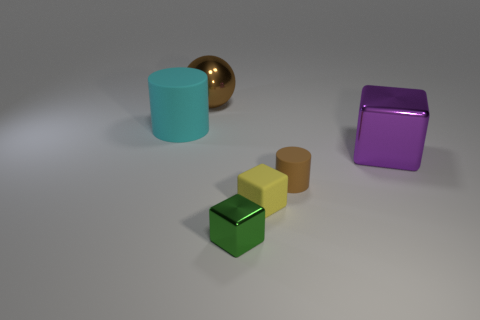How many other big cyan rubber objects have the same shape as the large rubber object?
Ensure brevity in your answer.  0. There is a block that is the same size as the yellow thing; what is its color?
Your answer should be very brief. Green. Are there the same number of big cyan objects right of the large matte cylinder and cylinders in front of the big purple object?
Your response must be concise. No. Is there a gray rubber cylinder that has the same size as the green cube?
Keep it short and to the point. No. The yellow cube has what size?
Make the answer very short. Small. Are there the same number of tiny yellow matte things behind the big brown metal object and tiny cyan blocks?
Make the answer very short. Yes. How many other objects are there of the same color as the shiny ball?
Ensure brevity in your answer.  1. What color is the metallic object that is both behind the tiny metallic cube and in front of the cyan matte thing?
Your answer should be compact. Purple. What size is the rubber cylinder in front of the big metallic thing that is in front of the big object that is on the left side of the large brown metal sphere?
Ensure brevity in your answer.  Small. How many objects are either large metal objects that are to the left of the brown rubber cylinder or matte things that are to the right of the brown metallic object?
Offer a terse response. 3. 